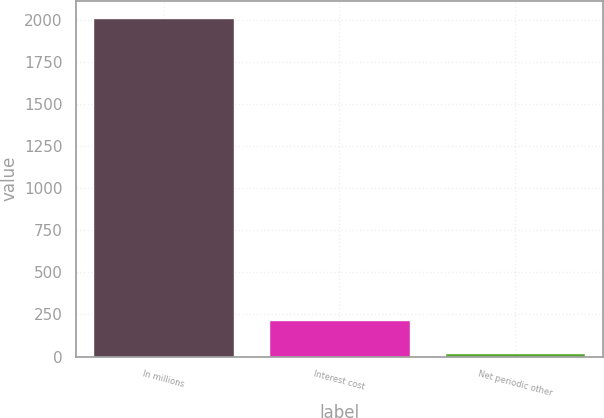Convert chart to OTSL. <chart><loc_0><loc_0><loc_500><loc_500><bar_chart><fcel>In millions<fcel>Interest cost<fcel>Net periodic other<nl><fcel>2012<fcel>219.2<fcel>20<nl></chart> 